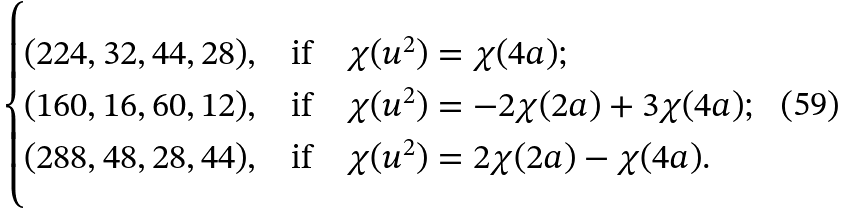Convert formula to latex. <formula><loc_0><loc_0><loc_500><loc_500>\begin{cases} ( 2 2 4 , 3 2 , 4 4 , 2 8 ) , & \text {if} \quad \chi ( u ^ { 2 } ) = \chi ( 4 a ) ; \\ ( 1 6 0 , 1 6 , 6 0 , 1 2 ) , & \text {if} \quad \chi ( u ^ { 2 } ) = - 2 \chi ( 2 a ) + 3 \chi ( 4 a ) ; \\ ( 2 8 8 , 4 8 , 2 8 , 4 4 ) , & \text {if} \quad \chi ( u ^ { 2 } ) = 2 \chi ( 2 a ) - \chi ( 4 a ) . \\ \end{cases}</formula> 